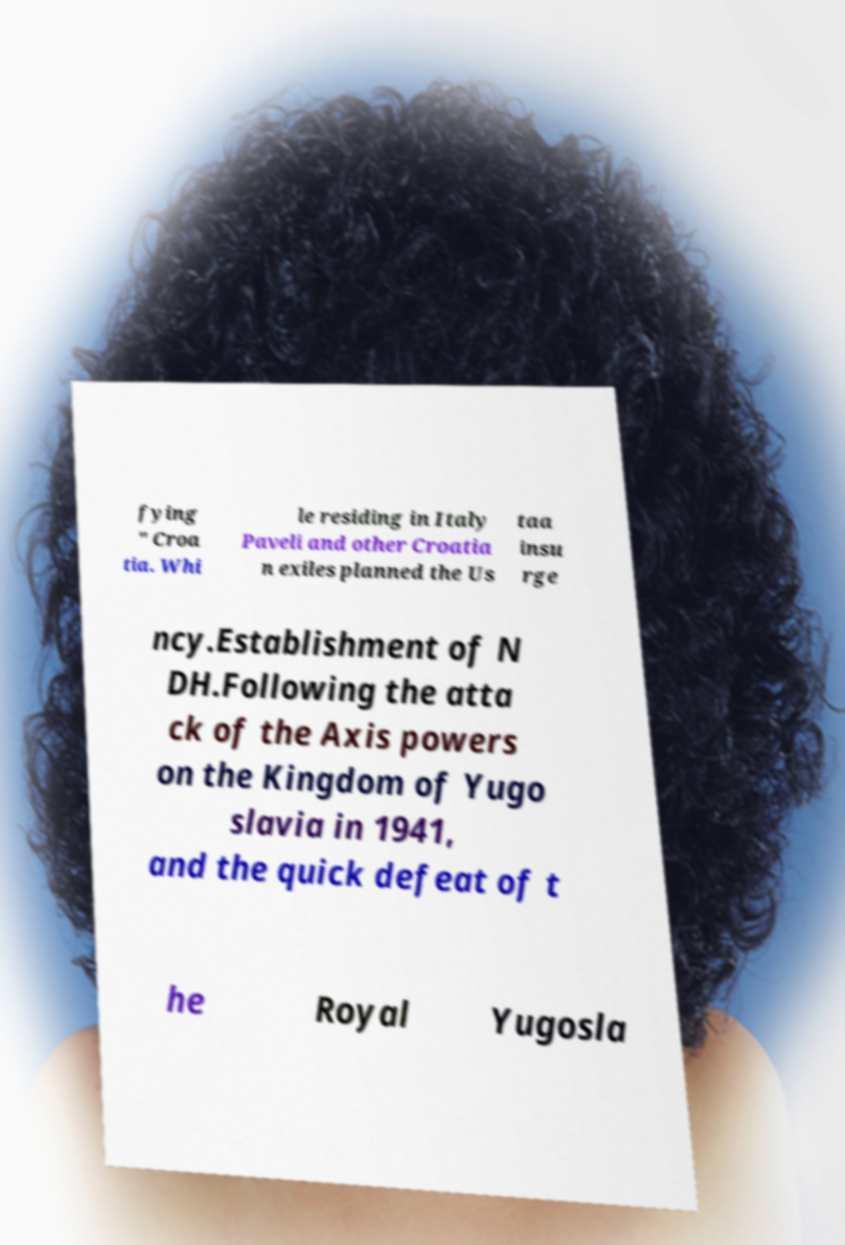Could you assist in decoding the text presented in this image and type it out clearly? fying " Croa tia. Whi le residing in Italy Paveli and other Croatia n exiles planned the Us taa insu rge ncy.Establishment of N DH.Following the atta ck of the Axis powers on the Kingdom of Yugo slavia in 1941, and the quick defeat of t he Royal Yugosla 